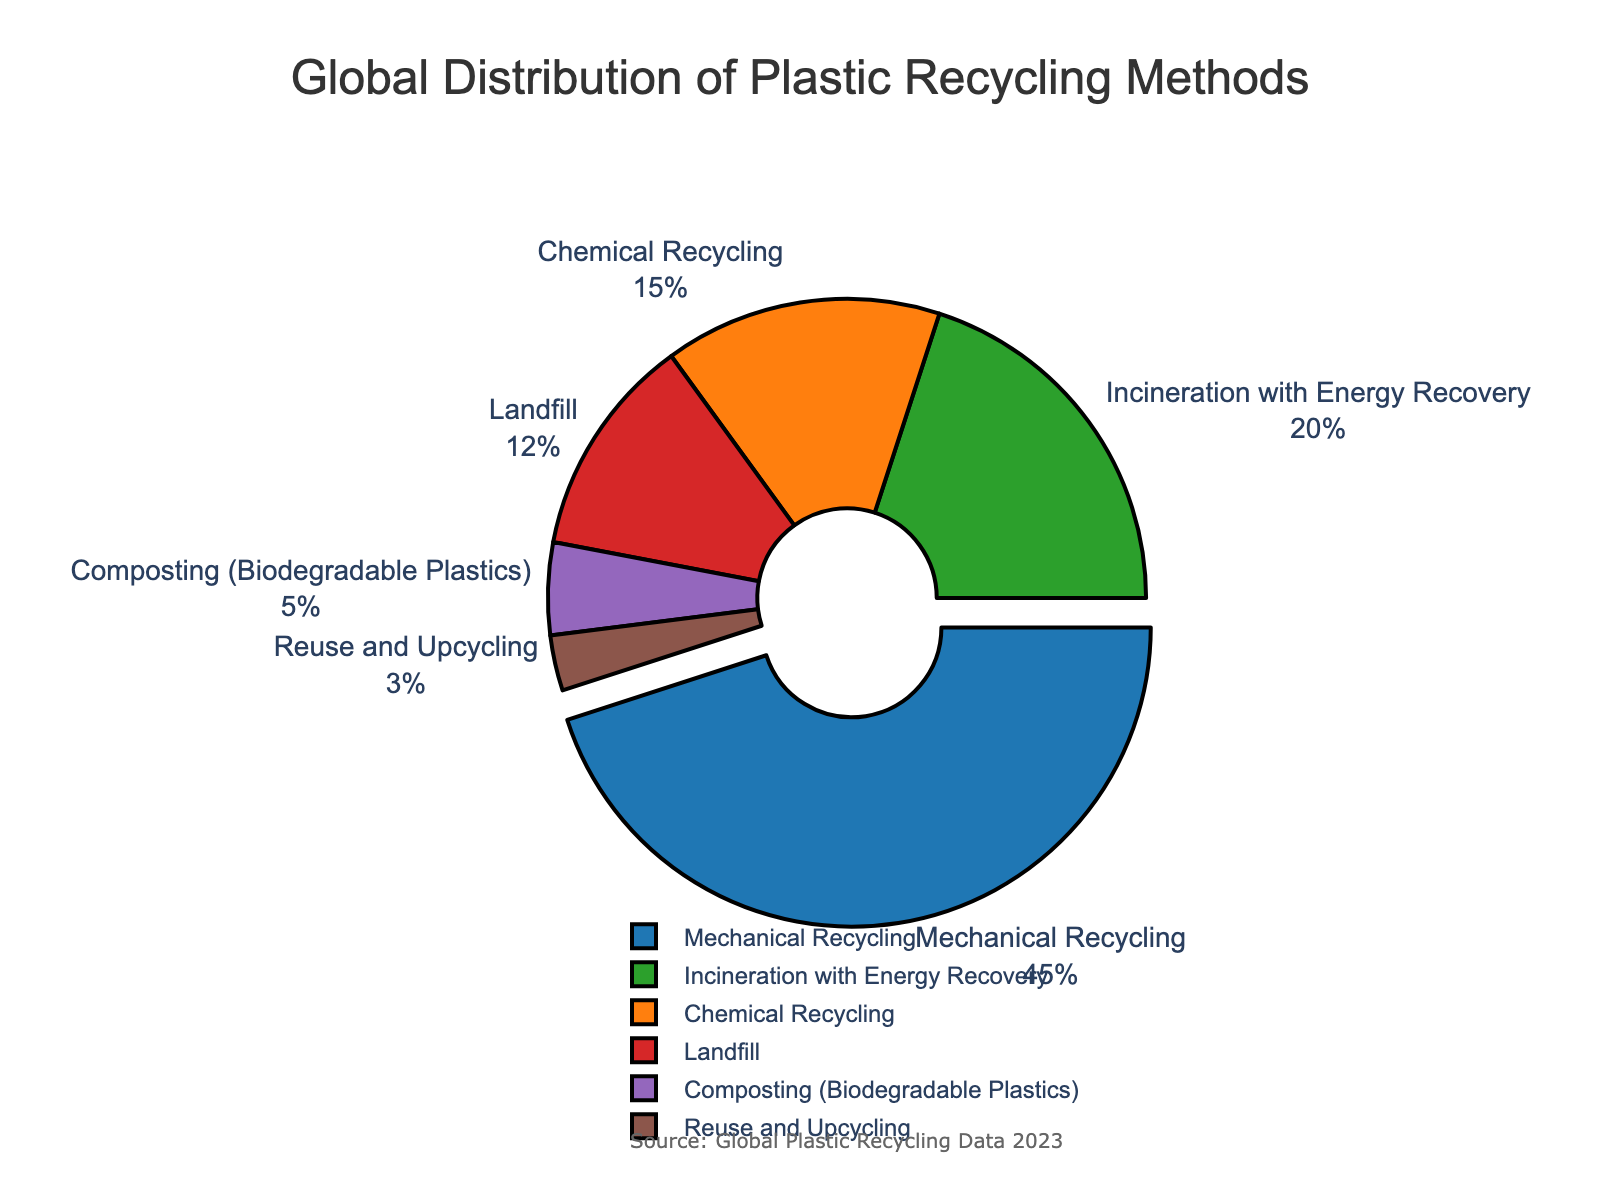What percentage of plastic recycling methods does Mechanical Recycling and Chemical Recycling together represent? To find the combined percentage, add the percentage of Mechanical Recycling (45%) and Chemical Recycling (15%). 45% + 15% = 60%.
Answer: 60% Which plastic recycling method has the least representation? Look for the recycling method with the smallest percentage. Reuse and Upcycling has 3%, which is the lowest.
Answer: Reuse and Upcycling Is the percentage of Incineration with Energy Recovery greater than or less than the percentage of Landfill recycling? Compare the percentages of Incineration with Energy Recovery (20%) and Landfill (12%). 20% is greater than 12%.
Answer: Greater What is the total percentage of non-recycling methods (Incineration with Energy Recovery and Landfill)? Add the percentages of Incineration with Energy Recovery (20%) and Landfill (12%). 20% + 12% = 32%.
Answer: 32% How much more common is Mechanical Recycling compared to Composting (Biodegradable Plastics)? Subtract the percentage of Composting (Biodegradable Plastics) from Mechanical Recycling. 45% - 5% = 40%.
Answer: 40% Which method represents a quarter of the global distribution of plastic recycling methods? Look for a method that is approximately 25% of the total. None of the recycling methods listed is exactly 25%, but Mechanical Recycling is the closest with 45%.
Answer: None If we group Mechanical Recycling and Chemical Recycling together as "Recycling" and the rest as "Non-Recycling," what is the percentage of Non-Recycling methods? First calculate the total percentage of Recycling (45% for Mechanical + 15% for Chemical = 60%). Then subtract this from 100% to find the Non-Recycling percentage. 100% - 60% = 40%.
Answer: 40% Which method is highlighted (pulled out) on the pie chart? The method with the highest percentage is usually highlighted. Mechanical Recycling, with 45%, is the highest and therefore highlighted.
Answer: Mechanical Recycling What is the difference in percentage points between Incineration with Energy Recovery and Chemical Recycling? Subtract the percentage of Chemical Recycling from Incineration with Energy Recovery. 20% - 15% = 5%.
Answer: 5% What color represents Landfill on the chart? Visually identify the section labeled Landfill and note its color. The given colors indicate a color like red represents Landfill.
Answer: Red 